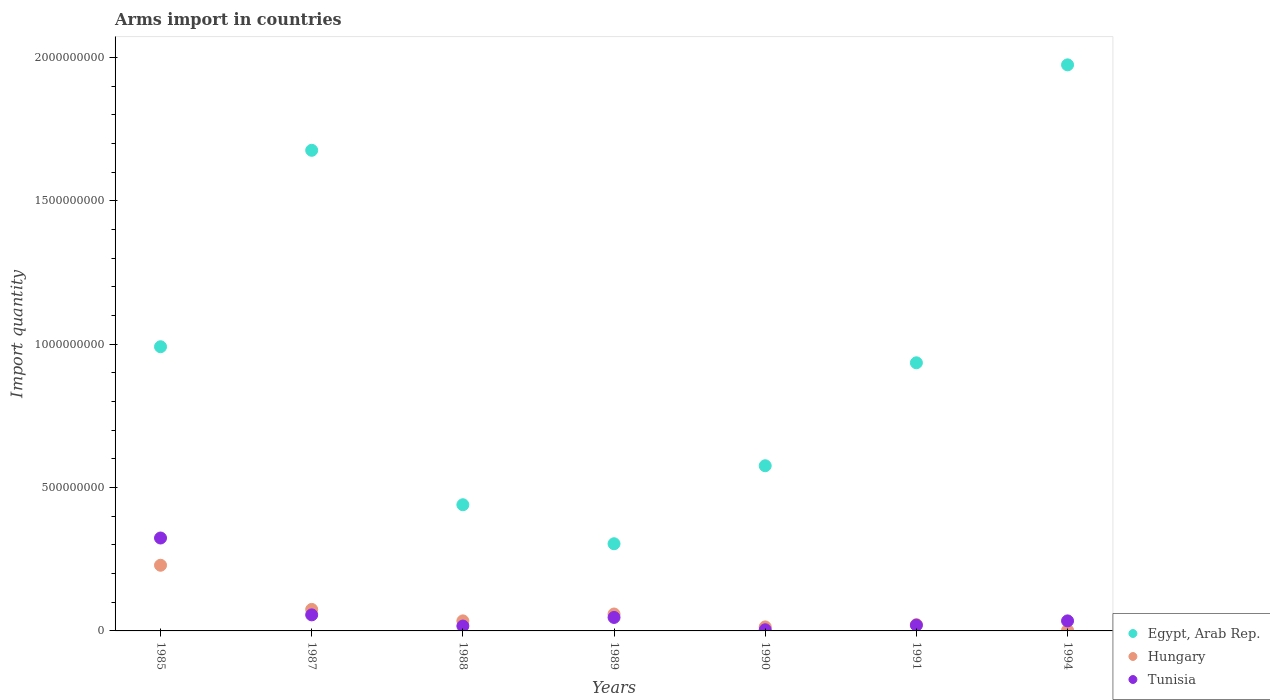How many different coloured dotlines are there?
Provide a succinct answer. 3. What is the total arms import in Hungary in 1990?
Offer a terse response. 1.40e+07. Across all years, what is the maximum total arms import in Egypt, Arab Rep.?
Give a very brief answer. 1.97e+09. Across all years, what is the minimum total arms import in Egypt, Arab Rep.?
Give a very brief answer. 3.04e+08. In which year was the total arms import in Tunisia maximum?
Offer a very short reply. 1985. In which year was the total arms import in Hungary minimum?
Your answer should be compact. 1994. What is the total total arms import in Tunisia in the graph?
Provide a succinct answer. 5.03e+08. What is the difference between the total arms import in Egypt, Arab Rep. in 1988 and that in 1991?
Provide a succinct answer. -4.95e+08. What is the difference between the total arms import in Tunisia in 1988 and the total arms import in Hungary in 1990?
Offer a very short reply. 3.00e+06. What is the average total arms import in Egypt, Arab Rep. per year?
Your answer should be compact. 9.85e+08. In the year 1989, what is the difference between the total arms import in Tunisia and total arms import in Hungary?
Offer a very short reply. -1.20e+07. In how many years, is the total arms import in Tunisia greater than 800000000?
Your answer should be compact. 0. What is the ratio of the total arms import in Hungary in 1990 to that in 1991?
Keep it short and to the point. 0.64. Is the total arms import in Tunisia in 1988 less than that in 1989?
Your response must be concise. Yes. Is the difference between the total arms import in Tunisia in 1990 and 1994 greater than the difference between the total arms import in Hungary in 1990 and 1994?
Your answer should be very brief. No. What is the difference between the highest and the second highest total arms import in Tunisia?
Offer a terse response. 2.68e+08. What is the difference between the highest and the lowest total arms import in Egypt, Arab Rep.?
Ensure brevity in your answer.  1.67e+09. Does the total arms import in Egypt, Arab Rep. monotonically increase over the years?
Offer a terse response. No. Is the total arms import in Tunisia strictly greater than the total arms import in Hungary over the years?
Your answer should be compact. No. Is the total arms import in Tunisia strictly less than the total arms import in Egypt, Arab Rep. over the years?
Ensure brevity in your answer.  Yes. How many dotlines are there?
Offer a very short reply. 3. Are the values on the major ticks of Y-axis written in scientific E-notation?
Offer a very short reply. No. What is the title of the graph?
Your answer should be very brief. Arms import in countries. Does "Niger" appear as one of the legend labels in the graph?
Make the answer very short. No. What is the label or title of the X-axis?
Offer a terse response. Years. What is the label or title of the Y-axis?
Your response must be concise. Import quantity. What is the Import quantity in Egypt, Arab Rep. in 1985?
Offer a terse response. 9.91e+08. What is the Import quantity of Hungary in 1985?
Provide a short and direct response. 2.29e+08. What is the Import quantity in Tunisia in 1985?
Provide a short and direct response. 3.24e+08. What is the Import quantity in Egypt, Arab Rep. in 1987?
Provide a succinct answer. 1.68e+09. What is the Import quantity of Hungary in 1987?
Offer a very short reply. 7.50e+07. What is the Import quantity in Tunisia in 1987?
Ensure brevity in your answer.  5.60e+07. What is the Import quantity in Egypt, Arab Rep. in 1988?
Your answer should be very brief. 4.40e+08. What is the Import quantity of Hungary in 1988?
Provide a succinct answer. 3.50e+07. What is the Import quantity of Tunisia in 1988?
Offer a terse response. 1.70e+07. What is the Import quantity of Egypt, Arab Rep. in 1989?
Make the answer very short. 3.04e+08. What is the Import quantity in Hungary in 1989?
Your answer should be very brief. 5.90e+07. What is the Import quantity of Tunisia in 1989?
Offer a terse response. 4.70e+07. What is the Import quantity in Egypt, Arab Rep. in 1990?
Your response must be concise. 5.76e+08. What is the Import quantity in Hungary in 1990?
Keep it short and to the point. 1.40e+07. What is the Import quantity in Tunisia in 1990?
Offer a very short reply. 4.00e+06. What is the Import quantity in Egypt, Arab Rep. in 1991?
Give a very brief answer. 9.35e+08. What is the Import quantity of Hungary in 1991?
Ensure brevity in your answer.  2.20e+07. What is the Import quantity in Egypt, Arab Rep. in 1994?
Offer a very short reply. 1.97e+09. What is the Import quantity of Tunisia in 1994?
Make the answer very short. 3.50e+07. Across all years, what is the maximum Import quantity of Egypt, Arab Rep.?
Ensure brevity in your answer.  1.97e+09. Across all years, what is the maximum Import quantity of Hungary?
Your response must be concise. 2.29e+08. Across all years, what is the maximum Import quantity of Tunisia?
Offer a very short reply. 3.24e+08. Across all years, what is the minimum Import quantity in Egypt, Arab Rep.?
Provide a short and direct response. 3.04e+08. What is the total Import quantity of Egypt, Arab Rep. in the graph?
Give a very brief answer. 6.90e+09. What is the total Import quantity in Hungary in the graph?
Offer a terse response. 4.36e+08. What is the total Import quantity in Tunisia in the graph?
Ensure brevity in your answer.  5.03e+08. What is the difference between the Import quantity of Egypt, Arab Rep. in 1985 and that in 1987?
Make the answer very short. -6.85e+08. What is the difference between the Import quantity in Hungary in 1985 and that in 1987?
Your answer should be very brief. 1.54e+08. What is the difference between the Import quantity in Tunisia in 1985 and that in 1987?
Provide a succinct answer. 2.68e+08. What is the difference between the Import quantity of Egypt, Arab Rep. in 1985 and that in 1988?
Give a very brief answer. 5.51e+08. What is the difference between the Import quantity of Hungary in 1985 and that in 1988?
Ensure brevity in your answer.  1.94e+08. What is the difference between the Import quantity in Tunisia in 1985 and that in 1988?
Provide a succinct answer. 3.07e+08. What is the difference between the Import quantity of Egypt, Arab Rep. in 1985 and that in 1989?
Ensure brevity in your answer.  6.87e+08. What is the difference between the Import quantity in Hungary in 1985 and that in 1989?
Make the answer very short. 1.70e+08. What is the difference between the Import quantity of Tunisia in 1985 and that in 1989?
Offer a terse response. 2.77e+08. What is the difference between the Import quantity in Egypt, Arab Rep. in 1985 and that in 1990?
Your response must be concise. 4.15e+08. What is the difference between the Import quantity in Hungary in 1985 and that in 1990?
Offer a terse response. 2.15e+08. What is the difference between the Import quantity in Tunisia in 1985 and that in 1990?
Your response must be concise. 3.20e+08. What is the difference between the Import quantity of Egypt, Arab Rep. in 1985 and that in 1991?
Your answer should be compact. 5.60e+07. What is the difference between the Import quantity of Hungary in 1985 and that in 1991?
Offer a very short reply. 2.07e+08. What is the difference between the Import quantity of Tunisia in 1985 and that in 1991?
Your answer should be very brief. 3.04e+08. What is the difference between the Import quantity of Egypt, Arab Rep. in 1985 and that in 1994?
Your answer should be very brief. -9.83e+08. What is the difference between the Import quantity of Hungary in 1985 and that in 1994?
Your response must be concise. 2.27e+08. What is the difference between the Import quantity in Tunisia in 1985 and that in 1994?
Keep it short and to the point. 2.89e+08. What is the difference between the Import quantity in Egypt, Arab Rep. in 1987 and that in 1988?
Your answer should be compact. 1.24e+09. What is the difference between the Import quantity of Hungary in 1987 and that in 1988?
Give a very brief answer. 4.00e+07. What is the difference between the Import quantity in Tunisia in 1987 and that in 1988?
Ensure brevity in your answer.  3.90e+07. What is the difference between the Import quantity in Egypt, Arab Rep. in 1987 and that in 1989?
Your answer should be compact. 1.37e+09. What is the difference between the Import quantity of Hungary in 1987 and that in 1989?
Your answer should be very brief. 1.60e+07. What is the difference between the Import quantity of Tunisia in 1987 and that in 1989?
Offer a very short reply. 9.00e+06. What is the difference between the Import quantity in Egypt, Arab Rep. in 1987 and that in 1990?
Provide a succinct answer. 1.10e+09. What is the difference between the Import quantity in Hungary in 1987 and that in 1990?
Make the answer very short. 6.10e+07. What is the difference between the Import quantity of Tunisia in 1987 and that in 1990?
Give a very brief answer. 5.20e+07. What is the difference between the Import quantity of Egypt, Arab Rep. in 1987 and that in 1991?
Keep it short and to the point. 7.41e+08. What is the difference between the Import quantity of Hungary in 1987 and that in 1991?
Ensure brevity in your answer.  5.30e+07. What is the difference between the Import quantity in Tunisia in 1987 and that in 1991?
Offer a very short reply. 3.60e+07. What is the difference between the Import quantity in Egypt, Arab Rep. in 1987 and that in 1994?
Make the answer very short. -2.98e+08. What is the difference between the Import quantity in Hungary in 1987 and that in 1994?
Your response must be concise. 7.30e+07. What is the difference between the Import quantity of Tunisia in 1987 and that in 1994?
Your response must be concise. 2.10e+07. What is the difference between the Import quantity in Egypt, Arab Rep. in 1988 and that in 1989?
Offer a very short reply. 1.36e+08. What is the difference between the Import quantity in Hungary in 1988 and that in 1989?
Make the answer very short. -2.40e+07. What is the difference between the Import quantity in Tunisia in 1988 and that in 1989?
Your answer should be compact. -3.00e+07. What is the difference between the Import quantity in Egypt, Arab Rep. in 1988 and that in 1990?
Offer a terse response. -1.36e+08. What is the difference between the Import quantity in Hungary in 1988 and that in 1990?
Your answer should be very brief. 2.10e+07. What is the difference between the Import quantity in Tunisia in 1988 and that in 1990?
Ensure brevity in your answer.  1.30e+07. What is the difference between the Import quantity in Egypt, Arab Rep. in 1988 and that in 1991?
Keep it short and to the point. -4.95e+08. What is the difference between the Import quantity of Hungary in 1988 and that in 1991?
Keep it short and to the point. 1.30e+07. What is the difference between the Import quantity in Egypt, Arab Rep. in 1988 and that in 1994?
Make the answer very short. -1.53e+09. What is the difference between the Import quantity of Hungary in 1988 and that in 1994?
Give a very brief answer. 3.30e+07. What is the difference between the Import quantity in Tunisia in 1988 and that in 1994?
Your answer should be very brief. -1.80e+07. What is the difference between the Import quantity in Egypt, Arab Rep. in 1989 and that in 1990?
Provide a short and direct response. -2.72e+08. What is the difference between the Import quantity in Hungary in 1989 and that in 1990?
Make the answer very short. 4.50e+07. What is the difference between the Import quantity of Tunisia in 1989 and that in 1990?
Your answer should be very brief. 4.30e+07. What is the difference between the Import quantity of Egypt, Arab Rep. in 1989 and that in 1991?
Provide a succinct answer. -6.31e+08. What is the difference between the Import quantity in Hungary in 1989 and that in 1991?
Provide a short and direct response. 3.70e+07. What is the difference between the Import quantity of Tunisia in 1989 and that in 1991?
Your response must be concise. 2.70e+07. What is the difference between the Import quantity of Egypt, Arab Rep. in 1989 and that in 1994?
Ensure brevity in your answer.  -1.67e+09. What is the difference between the Import quantity of Hungary in 1989 and that in 1994?
Your response must be concise. 5.70e+07. What is the difference between the Import quantity in Egypt, Arab Rep. in 1990 and that in 1991?
Your answer should be compact. -3.59e+08. What is the difference between the Import quantity of Hungary in 1990 and that in 1991?
Provide a short and direct response. -8.00e+06. What is the difference between the Import quantity in Tunisia in 1990 and that in 1991?
Ensure brevity in your answer.  -1.60e+07. What is the difference between the Import quantity in Egypt, Arab Rep. in 1990 and that in 1994?
Provide a succinct answer. -1.40e+09. What is the difference between the Import quantity in Hungary in 1990 and that in 1994?
Your answer should be compact. 1.20e+07. What is the difference between the Import quantity in Tunisia in 1990 and that in 1994?
Offer a terse response. -3.10e+07. What is the difference between the Import quantity of Egypt, Arab Rep. in 1991 and that in 1994?
Offer a terse response. -1.04e+09. What is the difference between the Import quantity in Tunisia in 1991 and that in 1994?
Provide a short and direct response. -1.50e+07. What is the difference between the Import quantity of Egypt, Arab Rep. in 1985 and the Import quantity of Hungary in 1987?
Provide a succinct answer. 9.16e+08. What is the difference between the Import quantity of Egypt, Arab Rep. in 1985 and the Import quantity of Tunisia in 1987?
Provide a short and direct response. 9.35e+08. What is the difference between the Import quantity of Hungary in 1985 and the Import quantity of Tunisia in 1987?
Provide a short and direct response. 1.73e+08. What is the difference between the Import quantity in Egypt, Arab Rep. in 1985 and the Import quantity in Hungary in 1988?
Your response must be concise. 9.56e+08. What is the difference between the Import quantity of Egypt, Arab Rep. in 1985 and the Import quantity of Tunisia in 1988?
Make the answer very short. 9.74e+08. What is the difference between the Import quantity in Hungary in 1985 and the Import quantity in Tunisia in 1988?
Provide a short and direct response. 2.12e+08. What is the difference between the Import quantity in Egypt, Arab Rep. in 1985 and the Import quantity in Hungary in 1989?
Offer a terse response. 9.32e+08. What is the difference between the Import quantity in Egypt, Arab Rep. in 1985 and the Import quantity in Tunisia in 1989?
Give a very brief answer. 9.44e+08. What is the difference between the Import quantity in Hungary in 1985 and the Import quantity in Tunisia in 1989?
Your response must be concise. 1.82e+08. What is the difference between the Import quantity of Egypt, Arab Rep. in 1985 and the Import quantity of Hungary in 1990?
Your answer should be compact. 9.77e+08. What is the difference between the Import quantity of Egypt, Arab Rep. in 1985 and the Import quantity of Tunisia in 1990?
Keep it short and to the point. 9.87e+08. What is the difference between the Import quantity of Hungary in 1985 and the Import quantity of Tunisia in 1990?
Offer a very short reply. 2.25e+08. What is the difference between the Import quantity in Egypt, Arab Rep. in 1985 and the Import quantity in Hungary in 1991?
Your answer should be very brief. 9.69e+08. What is the difference between the Import quantity of Egypt, Arab Rep. in 1985 and the Import quantity of Tunisia in 1991?
Ensure brevity in your answer.  9.71e+08. What is the difference between the Import quantity of Hungary in 1985 and the Import quantity of Tunisia in 1991?
Offer a very short reply. 2.09e+08. What is the difference between the Import quantity in Egypt, Arab Rep. in 1985 and the Import quantity in Hungary in 1994?
Give a very brief answer. 9.89e+08. What is the difference between the Import quantity of Egypt, Arab Rep. in 1985 and the Import quantity of Tunisia in 1994?
Provide a succinct answer. 9.56e+08. What is the difference between the Import quantity in Hungary in 1985 and the Import quantity in Tunisia in 1994?
Offer a very short reply. 1.94e+08. What is the difference between the Import quantity of Egypt, Arab Rep. in 1987 and the Import quantity of Hungary in 1988?
Offer a terse response. 1.64e+09. What is the difference between the Import quantity of Egypt, Arab Rep. in 1987 and the Import quantity of Tunisia in 1988?
Keep it short and to the point. 1.66e+09. What is the difference between the Import quantity of Hungary in 1987 and the Import quantity of Tunisia in 1988?
Give a very brief answer. 5.80e+07. What is the difference between the Import quantity of Egypt, Arab Rep. in 1987 and the Import quantity of Hungary in 1989?
Your response must be concise. 1.62e+09. What is the difference between the Import quantity in Egypt, Arab Rep. in 1987 and the Import quantity in Tunisia in 1989?
Your answer should be compact. 1.63e+09. What is the difference between the Import quantity in Hungary in 1987 and the Import quantity in Tunisia in 1989?
Ensure brevity in your answer.  2.80e+07. What is the difference between the Import quantity of Egypt, Arab Rep. in 1987 and the Import quantity of Hungary in 1990?
Give a very brief answer. 1.66e+09. What is the difference between the Import quantity in Egypt, Arab Rep. in 1987 and the Import quantity in Tunisia in 1990?
Offer a terse response. 1.67e+09. What is the difference between the Import quantity of Hungary in 1987 and the Import quantity of Tunisia in 1990?
Provide a short and direct response. 7.10e+07. What is the difference between the Import quantity in Egypt, Arab Rep. in 1987 and the Import quantity in Hungary in 1991?
Your response must be concise. 1.65e+09. What is the difference between the Import quantity of Egypt, Arab Rep. in 1987 and the Import quantity of Tunisia in 1991?
Your response must be concise. 1.66e+09. What is the difference between the Import quantity of Hungary in 1987 and the Import quantity of Tunisia in 1991?
Ensure brevity in your answer.  5.50e+07. What is the difference between the Import quantity in Egypt, Arab Rep. in 1987 and the Import quantity in Hungary in 1994?
Your answer should be very brief. 1.67e+09. What is the difference between the Import quantity of Egypt, Arab Rep. in 1987 and the Import quantity of Tunisia in 1994?
Offer a terse response. 1.64e+09. What is the difference between the Import quantity of Hungary in 1987 and the Import quantity of Tunisia in 1994?
Your response must be concise. 4.00e+07. What is the difference between the Import quantity of Egypt, Arab Rep. in 1988 and the Import quantity of Hungary in 1989?
Ensure brevity in your answer.  3.81e+08. What is the difference between the Import quantity of Egypt, Arab Rep. in 1988 and the Import quantity of Tunisia in 1989?
Your answer should be very brief. 3.93e+08. What is the difference between the Import quantity in Hungary in 1988 and the Import quantity in Tunisia in 1989?
Ensure brevity in your answer.  -1.20e+07. What is the difference between the Import quantity in Egypt, Arab Rep. in 1988 and the Import quantity in Hungary in 1990?
Ensure brevity in your answer.  4.26e+08. What is the difference between the Import quantity in Egypt, Arab Rep. in 1988 and the Import quantity in Tunisia in 1990?
Make the answer very short. 4.36e+08. What is the difference between the Import quantity of Hungary in 1988 and the Import quantity of Tunisia in 1990?
Make the answer very short. 3.10e+07. What is the difference between the Import quantity of Egypt, Arab Rep. in 1988 and the Import quantity of Hungary in 1991?
Provide a succinct answer. 4.18e+08. What is the difference between the Import quantity in Egypt, Arab Rep. in 1988 and the Import quantity in Tunisia in 1991?
Your answer should be compact. 4.20e+08. What is the difference between the Import quantity of Hungary in 1988 and the Import quantity of Tunisia in 1991?
Provide a succinct answer. 1.50e+07. What is the difference between the Import quantity of Egypt, Arab Rep. in 1988 and the Import quantity of Hungary in 1994?
Your answer should be very brief. 4.38e+08. What is the difference between the Import quantity of Egypt, Arab Rep. in 1988 and the Import quantity of Tunisia in 1994?
Give a very brief answer. 4.05e+08. What is the difference between the Import quantity of Egypt, Arab Rep. in 1989 and the Import quantity of Hungary in 1990?
Offer a very short reply. 2.90e+08. What is the difference between the Import quantity of Egypt, Arab Rep. in 1989 and the Import quantity of Tunisia in 1990?
Give a very brief answer. 3.00e+08. What is the difference between the Import quantity in Hungary in 1989 and the Import quantity in Tunisia in 1990?
Offer a terse response. 5.50e+07. What is the difference between the Import quantity in Egypt, Arab Rep. in 1989 and the Import quantity in Hungary in 1991?
Offer a terse response. 2.82e+08. What is the difference between the Import quantity of Egypt, Arab Rep. in 1989 and the Import quantity of Tunisia in 1991?
Provide a succinct answer. 2.84e+08. What is the difference between the Import quantity in Hungary in 1989 and the Import quantity in Tunisia in 1991?
Provide a succinct answer. 3.90e+07. What is the difference between the Import quantity of Egypt, Arab Rep. in 1989 and the Import quantity of Hungary in 1994?
Provide a succinct answer. 3.02e+08. What is the difference between the Import quantity of Egypt, Arab Rep. in 1989 and the Import quantity of Tunisia in 1994?
Keep it short and to the point. 2.69e+08. What is the difference between the Import quantity in Hungary in 1989 and the Import quantity in Tunisia in 1994?
Your answer should be very brief. 2.40e+07. What is the difference between the Import quantity of Egypt, Arab Rep. in 1990 and the Import quantity of Hungary in 1991?
Your response must be concise. 5.54e+08. What is the difference between the Import quantity of Egypt, Arab Rep. in 1990 and the Import quantity of Tunisia in 1991?
Make the answer very short. 5.56e+08. What is the difference between the Import quantity of Hungary in 1990 and the Import quantity of Tunisia in 1991?
Provide a short and direct response. -6.00e+06. What is the difference between the Import quantity in Egypt, Arab Rep. in 1990 and the Import quantity in Hungary in 1994?
Offer a terse response. 5.74e+08. What is the difference between the Import quantity in Egypt, Arab Rep. in 1990 and the Import quantity in Tunisia in 1994?
Ensure brevity in your answer.  5.41e+08. What is the difference between the Import quantity in Hungary in 1990 and the Import quantity in Tunisia in 1994?
Make the answer very short. -2.10e+07. What is the difference between the Import quantity of Egypt, Arab Rep. in 1991 and the Import quantity of Hungary in 1994?
Your answer should be very brief. 9.33e+08. What is the difference between the Import quantity in Egypt, Arab Rep. in 1991 and the Import quantity in Tunisia in 1994?
Give a very brief answer. 9.00e+08. What is the difference between the Import quantity of Hungary in 1991 and the Import quantity of Tunisia in 1994?
Keep it short and to the point. -1.30e+07. What is the average Import quantity of Egypt, Arab Rep. per year?
Give a very brief answer. 9.85e+08. What is the average Import quantity in Hungary per year?
Provide a succinct answer. 6.23e+07. What is the average Import quantity of Tunisia per year?
Your response must be concise. 7.19e+07. In the year 1985, what is the difference between the Import quantity in Egypt, Arab Rep. and Import quantity in Hungary?
Your answer should be compact. 7.62e+08. In the year 1985, what is the difference between the Import quantity of Egypt, Arab Rep. and Import quantity of Tunisia?
Keep it short and to the point. 6.67e+08. In the year 1985, what is the difference between the Import quantity in Hungary and Import quantity in Tunisia?
Your answer should be very brief. -9.50e+07. In the year 1987, what is the difference between the Import quantity of Egypt, Arab Rep. and Import quantity of Hungary?
Offer a very short reply. 1.60e+09. In the year 1987, what is the difference between the Import quantity of Egypt, Arab Rep. and Import quantity of Tunisia?
Ensure brevity in your answer.  1.62e+09. In the year 1987, what is the difference between the Import quantity of Hungary and Import quantity of Tunisia?
Ensure brevity in your answer.  1.90e+07. In the year 1988, what is the difference between the Import quantity of Egypt, Arab Rep. and Import quantity of Hungary?
Your answer should be very brief. 4.05e+08. In the year 1988, what is the difference between the Import quantity of Egypt, Arab Rep. and Import quantity of Tunisia?
Provide a succinct answer. 4.23e+08. In the year 1988, what is the difference between the Import quantity in Hungary and Import quantity in Tunisia?
Offer a very short reply. 1.80e+07. In the year 1989, what is the difference between the Import quantity of Egypt, Arab Rep. and Import quantity of Hungary?
Your answer should be very brief. 2.45e+08. In the year 1989, what is the difference between the Import quantity of Egypt, Arab Rep. and Import quantity of Tunisia?
Give a very brief answer. 2.57e+08. In the year 1990, what is the difference between the Import quantity of Egypt, Arab Rep. and Import quantity of Hungary?
Your response must be concise. 5.62e+08. In the year 1990, what is the difference between the Import quantity of Egypt, Arab Rep. and Import quantity of Tunisia?
Offer a terse response. 5.72e+08. In the year 1991, what is the difference between the Import quantity in Egypt, Arab Rep. and Import quantity in Hungary?
Your response must be concise. 9.13e+08. In the year 1991, what is the difference between the Import quantity in Egypt, Arab Rep. and Import quantity in Tunisia?
Your answer should be compact. 9.15e+08. In the year 1994, what is the difference between the Import quantity in Egypt, Arab Rep. and Import quantity in Hungary?
Keep it short and to the point. 1.97e+09. In the year 1994, what is the difference between the Import quantity in Egypt, Arab Rep. and Import quantity in Tunisia?
Your answer should be compact. 1.94e+09. In the year 1994, what is the difference between the Import quantity of Hungary and Import quantity of Tunisia?
Make the answer very short. -3.30e+07. What is the ratio of the Import quantity of Egypt, Arab Rep. in 1985 to that in 1987?
Give a very brief answer. 0.59. What is the ratio of the Import quantity of Hungary in 1985 to that in 1987?
Offer a terse response. 3.05. What is the ratio of the Import quantity of Tunisia in 1985 to that in 1987?
Provide a short and direct response. 5.79. What is the ratio of the Import quantity of Egypt, Arab Rep. in 1985 to that in 1988?
Keep it short and to the point. 2.25. What is the ratio of the Import quantity in Hungary in 1985 to that in 1988?
Provide a short and direct response. 6.54. What is the ratio of the Import quantity in Tunisia in 1985 to that in 1988?
Offer a terse response. 19.06. What is the ratio of the Import quantity in Egypt, Arab Rep. in 1985 to that in 1989?
Offer a very short reply. 3.26. What is the ratio of the Import quantity of Hungary in 1985 to that in 1989?
Provide a succinct answer. 3.88. What is the ratio of the Import quantity of Tunisia in 1985 to that in 1989?
Ensure brevity in your answer.  6.89. What is the ratio of the Import quantity of Egypt, Arab Rep. in 1985 to that in 1990?
Make the answer very short. 1.72. What is the ratio of the Import quantity in Hungary in 1985 to that in 1990?
Keep it short and to the point. 16.36. What is the ratio of the Import quantity of Tunisia in 1985 to that in 1990?
Provide a succinct answer. 81. What is the ratio of the Import quantity of Egypt, Arab Rep. in 1985 to that in 1991?
Keep it short and to the point. 1.06. What is the ratio of the Import quantity of Hungary in 1985 to that in 1991?
Offer a terse response. 10.41. What is the ratio of the Import quantity of Egypt, Arab Rep. in 1985 to that in 1994?
Ensure brevity in your answer.  0.5. What is the ratio of the Import quantity of Hungary in 1985 to that in 1994?
Make the answer very short. 114.5. What is the ratio of the Import quantity in Tunisia in 1985 to that in 1994?
Your response must be concise. 9.26. What is the ratio of the Import quantity of Egypt, Arab Rep. in 1987 to that in 1988?
Offer a terse response. 3.81. What is the ratio of the Import quantity of Hungary in 1987 to that in 1988?
Your response must be concise. 2.14. What is the ratio of the Import quantity in Tunisia in 1987 to that in 1988?
Your answer should be compact. 3.29. What is the ratio of the Import quantity in Egypt, Arab Rep. in 1987 to that in 1989?
Offer a terse response. 5.51. What is the ratio of the Import quantity of Hungary in 1987 to that in 1989?
Keep it short and to the point. 1.27. What is the ratio of the Import quantity in Tunisia in 1987 to that in 1989?
Your answer should be compact. 1.19. What is the ratio of the Import quantity of Egypt, Arab Rep. in 1987 to that in 1990?
Offer a terse response. 2.91. What is the ratio of the Import quantity in Hungary in 1987 to that in 1990?
Your answer should be very brief. 5.36. What is the ratio of the Import quantity in Tunisia in 1987 to that in 1990?
Keep it short and to the point. 14. What is the ratio of the Import quantity of Egypt, Arab Rep. in 1987 to that in 1991?
Offer a terse response. 1.79. What is the ratio of the Import quantity of Hungary in 1987 to that in 1991?
Your answer should be compact. 3.41. What is the ratio of the Import quantity of Tunisia in 1987 to that in 1991?
Keep it short and to the point. 2.8. What is the ratio of the Import quantity in Egypt, Arab Rep. in 1987 to that in 1994?
Your response must be concise. 0.85. What is the ratio of the Import quantity of Hungary in 1987 to that in 1994?
Ensure brevity in your answer.  37.5. What is the ratio of the Import quantity of Egypt, Arab Rep. in 1988 to that in 1989?
Give a very brief answer. 1.45. What is the ratio of the Import quantity of Hungary in 1988 to that in 1989?
Your answer should be compact. 0.59. What is the ratio of the Import quantity in Tunisia in 1988 to that in 1989?
Provide a succinct answer. 0.36. What is the ratio of the Import quantity of Egypt, Arab Rep. in 1988 to that in 1990?
Provide a short and direct response. 0.76. What is the ratio of the Import quantity in Tunisia in 1988 to that in 1990?
Make the answer very short. 4.25. What is the ratio of the Import quantity in Egypt, Arab Rep. in 1988 to that in 1991?
Make the answer very short. 0.47. What is the ratio of the Import quantity in Hungary in 1988 to that in 1991?
Keep it short and to the point. 1.59. What is the ratio of the Import quantity in Tunisia in 1988 to that in 1991?
Offer a very short reply. 0.85. What is the ratio of the Import quantity in Egypt, Arab Rep. in 1988 to that in 1994?
Your answer should be compact. 0.22. What is the ratio of the Import quantity of Hungary in 1988 to that in 1994?
Give a very brief answer. 17.5. What is the ratio of the Import quantity of Tunisia in 1988 to that in 1994?
Provide a succinct answer. 0.49. What is the ratio of the Import quantity in Egypt, Arab Rep. in 1989 to that in 1990?
Offer a terse response. 0.53. What is the ratio of the Import quantity of Hungary in 1989 to that in 1990?
Give a very brief answer. 4.21. What is the ratio of the Import quantity in Tunisia in 1989 to that in 1990?
Give a very brief answer. 11.75. What is the ratio of the Import quantity of Egypt, Arab Rep. in 1989 to that in 1991?
Your response must be concise. 0.33. What is the ratio of the Import quantity in Hungary in 1989 to that in 1991?
Keep it short and to the point. 2.68. What is the ratio of the Import quantity in Tunisia in 1989 to that in 1991?
Offer a terse response. 2.35. What is the ratio of the Import quantity of Egypt, Arab Rep. in 1989 to that in 1994?
Keep it short and to the point. 0.15. What is the ratio of the Import quantity in Hungary in 1989 to that in 1994?
Offer a very short reply. 29.5. What is the ratio of the Import quantity in Tunisia in 1989 to that in 1994?
Your response must be concise. 1.34. What is the ratio of the Import quantity in Egypt, Arab Rep. in 1990 to that in 1991?
Keep it short and to the point. 0.62. What is the ratio of the Import quantity of Hungary in 1990 to that in 1991?
Keep it short and to the point. 0.64. What is the ratio of the Import quantity in Tunisia in 1990 to that in 1991?
Provide a succinct answer. 0.2. What is the ratio of the Import quantity of Egypt, Arab Rep. in 1990 to that in 1994?
Offer a very short reply. 0.29. What is the ratio of the Import quantity of Tunisia in 1990 to that in 1994?
Keep it short and to the point. 0.11. What is the ratio of the Import quantity of Egypt, Arab Rep. in 1991 to that in 1994?
Provide a succinct answer. 0.47. What is the ratio of the Import quantity of Tunisia in 1991 to that in 1994?
Offer a terse response. 0.57. What is the difference between the highest and the second highest Import quantity of Egypt, Arab Rep.?
Your response must be concise. 2.98e+08. What is the difference between the highest and the second highest Import quantity of Hungary?
Provide a succinct answer. 1.54e+08. What is the difference between the highest and the second highest Import quantity of Tunisia?
Your answer should be very brief. 2.68e+08. What is the difference between the highest and the lowest Import quantity in Egypt, Arab Rep.?
Your answer should be compact. 1.67e+09. What is the difference between the highest and the lowest Import quantity of Hungary?
Your response must be concise. 2.27e+08. What is the difference between the highest and the lowest Import quantity in Tunisia?
Offer a very short reply. 3.20e+08. 